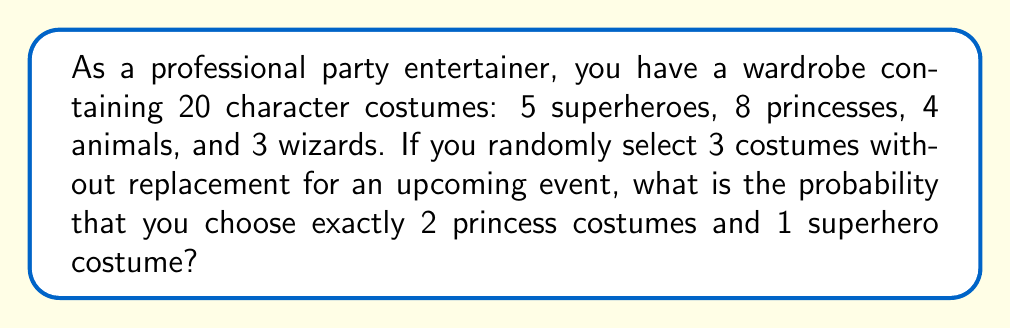Can you answer this question? Let's approach this step-by-step using the hypergeometric distribution:

1) We need to choose 2 princesses out of 8, and 1 superhero out of 5, from a total of 20 costumes.

2) The number of ways to choose 2 princesses out of 8:
   $$\binom{8}{2} = \frac{8!}{2!(8-2)!} = \frac{8 \cdot 7}{2 \cdot 1} = 28$$

3) The number of ways to choose 1 superhero out of 5:
   $$\binom{5}{1} = 5$$

4) The total number of ways to choose 3 costumes out of 20:
   $$\binom{20}{3} = \frac{20!}{3!(20-3)!} = \frac{20 \cdot 19 \cdot 18}{3 \cdot 2 \cdot 1} = 1140$$

5) The probability is the number of favorable outcomes divided by the total number of possible outcomes:

   $$P(\text{2 princesses and 1 superhero}) = \frac{\binom{8}{2} \cdot \binom{5}{1}}{\binom{20}{3}} = \frac{28 \cdot 5}{1140} = \frac{140}{1140} = \frac{7}{57}$$
Answer: $\frac{7}{57}$ or approximately 0.1228 